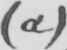What does this handwritten line say? ( a ) 